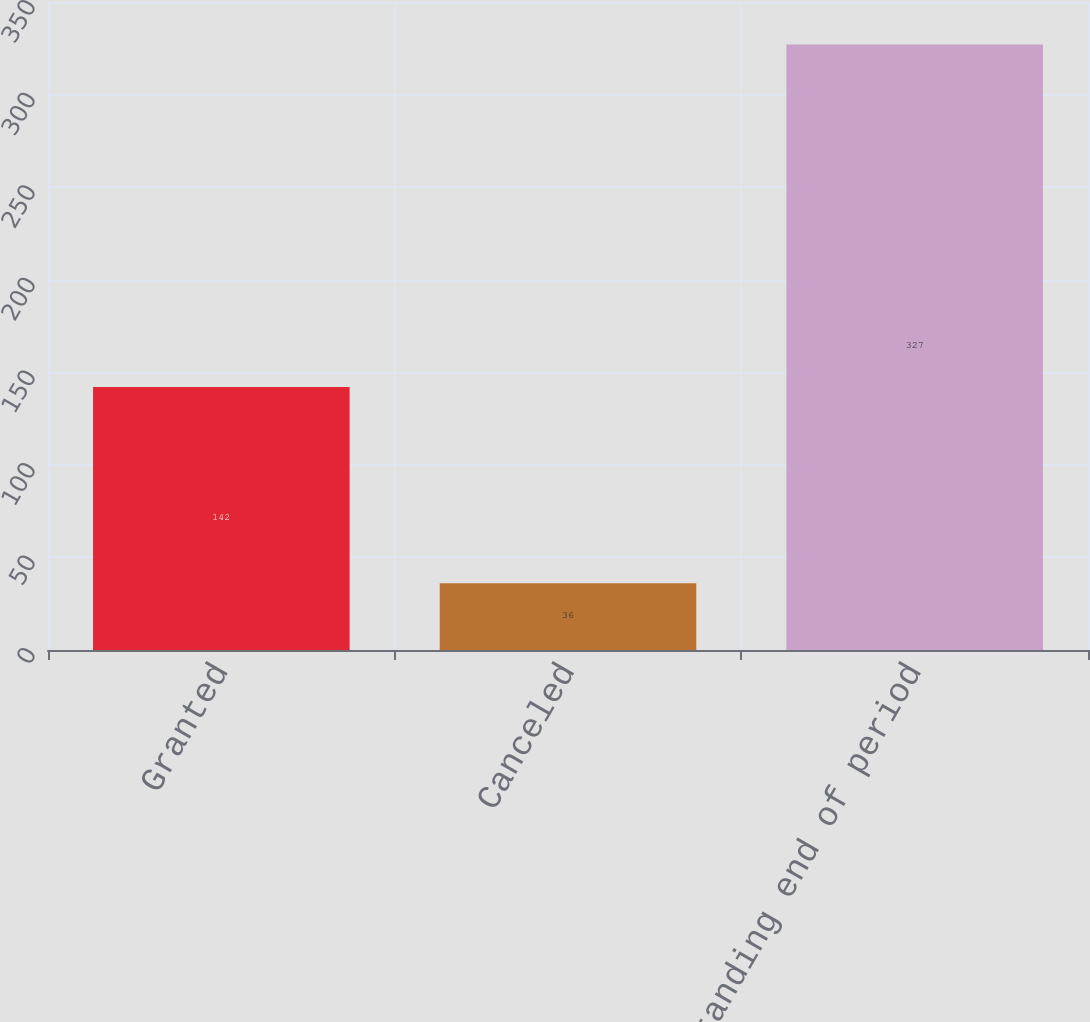Convert chart to OTSL. <chart><loc_0><loc_0><loc_500><loc_500><bar_chart><fcel>Granted<fcel>Canceled<fcel>Outstanding end of period<nl><fcel>142<fcel>36<fcel>327<nl></chart> 